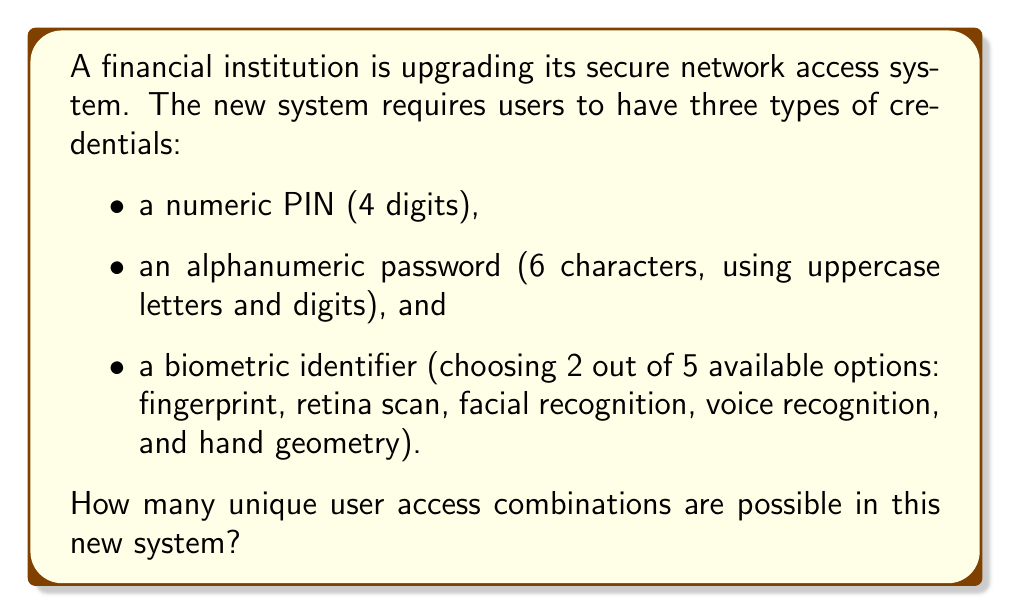Give your solution to this math problem. Let's break this down step-by-step:

1. Numeric PIN:
   - 4 digits, each can be 0-9
   - Total combinations: $10^4 = 10,000$

2. Alphanumeric password:
   - 6 characters, each can be an uppercase letter (26 options) or a digit (10 options)
   - Total options per character: 26 + 10 = 36
   - Total combinations: $36^6 = 2,176,782,336$

3. Biometric identifier:
   - Choosing 2 out of 5 options
   - This is a combination problem, calculated as $\binom{5}{2} = \frac{5!}{2!(5-2)!} = 10$

Now, to find the total number of unique combinations, we multiply these together:

$$\text{Total combinations} = 10,000 \times 2,176,782,336 \times 10$$

$$= 217,678,233,600,000$$

This large number represents the significantly increased security due to the combination of multiple authentication factors.
Answer: $217,678,233,600,000$ 